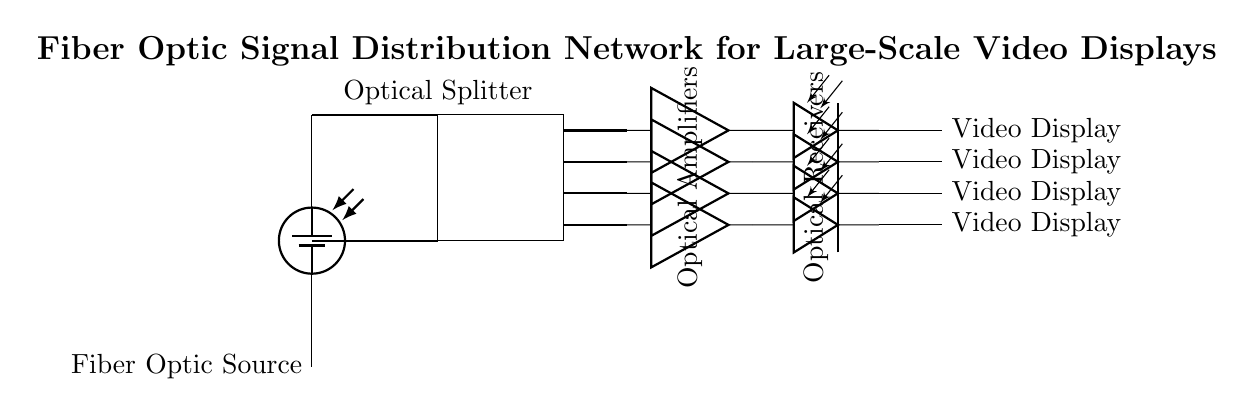What is the main component that distributes the fiber optic signal? The main component responsible for distributing the fiber optic signal in the diagram is the optical splitter, which takes the input signal and splits it into multiple outputs for further distribution.
Answer: Optical Splitter How many optical amplifiers are present in the circuit? The circuit contains four optical amplifiers, as indicated by the parallel lines drawn next to the optical receivers, each connected to separate outputs of the splitter.
Answer: Four What is the function of the optical receiver in this circuit? The optical receiver is responsible for converting the optical signal back into an electrical signal that can be processed by the video displays, enabling the visual representation of the video content.
Answer: Converting optical to electrical signal Which component is located immediately after the optical splitter? Immediately after the optical splitter, the next component in the circuit is the optical amplifier, which receives the split signals and boosts them to maintain signal integrity across longer distances.
Answer: Optical Amplifier What type of signal is mainly being distributed in this circuit? The signal primarily being distributed in this circuit is an optical signal, which allows for high-speed data transmission over fiber optic cables, particularly suitable for video displays.
Answer: Optical Signal What is the end output device connected to the circuit? The circuit ends with video displays, which receive the processed signals from the optical receivers and render the visual content for the audience to view.
Answer: Video Displays 